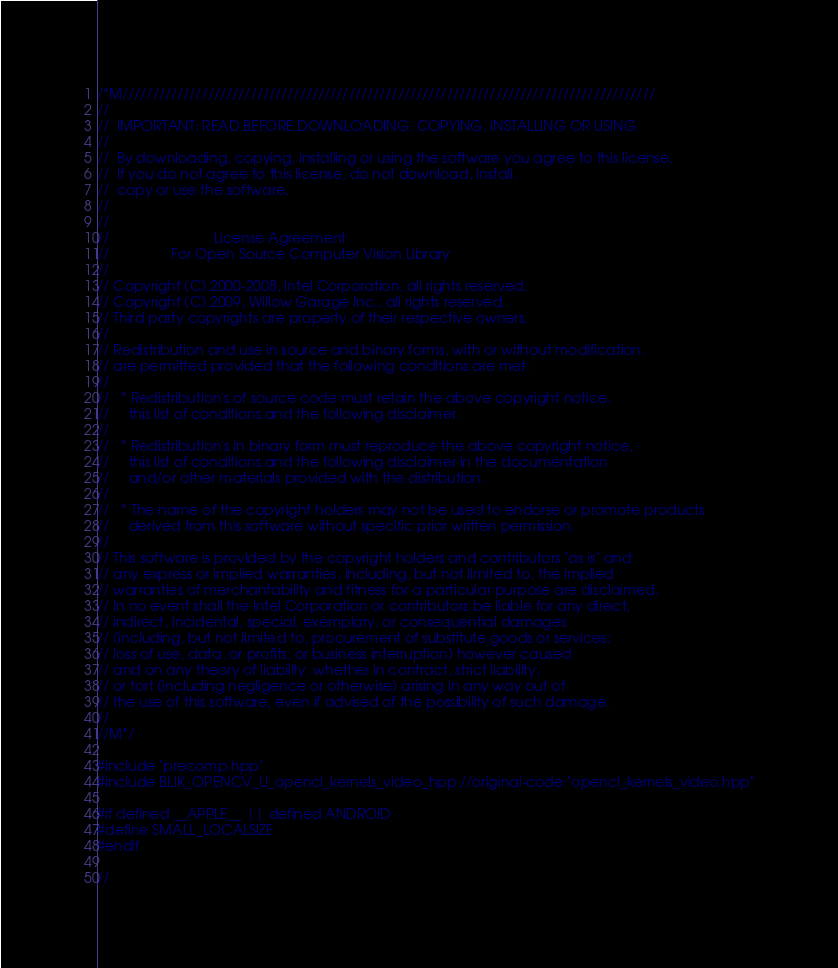<code> <loc_0><loc_0><loc_500><loc_500><_C++_>/*M///////////////////////////////////////////////////////////////////////////////////////
//
//  IMPORTANT: READ BEFORE DOWNLOADING, COPYING, INSTALLING OR USING.
//
//  By downloading, copying, installing or using the software you agree to this license.
//  If you do not agree to this license, do not download, install,
//  copy or use the software.
//
//
//                           License Agreement
//                For Open Source Computer Vision Library
//
// Copyright (C) 2000-2008, Intel Corporation, all rights reserved.
// Copyright (C) 2009, Willow Garage Inc., all rights reserved.
// Third party copyrights are property of their respective owners.
//
// Redistribution and use in source and binary forms, with or without modification,
// are permitted provided that the following conditions are met:
//
//   * Redistribution's of source code must retain the above copyright notice,
//     this list of conditions and the following disclaimer.
//
//   * Redistribution's in binary form must reproduce the above copyright notice,
//     this list of conditions and the following disclaimer in the documentation
//     and/or other materials provided with the distribution.
//
//   * The name of the copyright holders may not be used to endorse or promote products
//     derived from this software without specific prior written permission.
//
// This software is provided by the copyright holders and contributors "as is" and
// any express or implied warranties, including, but not limited to, the implied
// warranties of merchantability and fitness for a particular purpose are disclaimed.
// In no event shall the Intel Corporation or contributors be liable for any direct,
// indirect, incidental, special, exemplary, or consequential damages
// (including, but not limited to, procurement of substitute goods or services;
// loss of use, data, or profits; or business interruption) however caused
// and on any theory of liability, whether in contract, strict liability,
// or tort (including negligence or otherwise) arising in any way out of
// the use of this software, even if advised of the possibility of such damage.
//
//M*/

#include "precomp.hpp"
#include BLIK_OPENCV_U_opencl_kernels_video_hpp //original-code:"opencl_kernels_video.hpp"

#if defined __APPLE__ || defined ANDROID
#define SMALL_LOCALSIZE
#endif

//</code> 